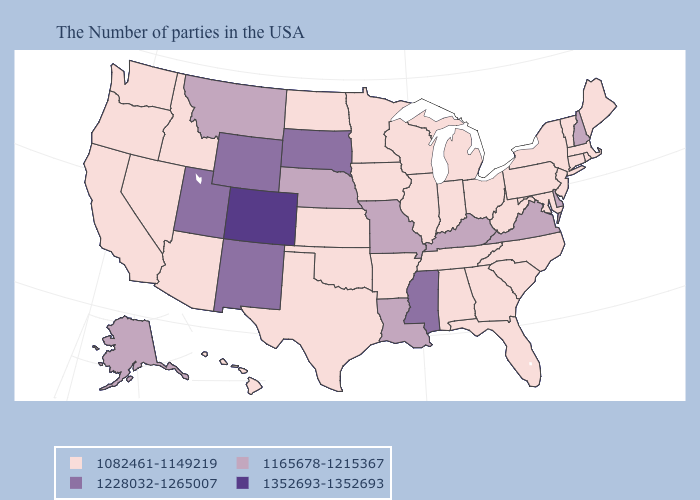Name the states that have a value in the range 1228032-1265007?
Be succinct. Mississippi, South Dakota, Wyoming, New Mexico, Utah. Name the states that have a value in the range 1165678-1215367?
Quick response, please. New Hampshire, Delaware, Virginia, Kentucky, Louisiana, Missouri, Nebraska, Montana, Alaska. Which states hav the highest value in the South?
Write a very short answer. Mississippi. Name the states that have a value in the range 1352693-1352693?
Be succinct. Colorado. Name the states that have a value in the range 1228032-1265007?
Quick response, please. Mississippi, South Dakota, Wyoming, New Mexico, Utah. Among the states that border North Dakota , which have the highest value?
Answer briefly. South Dakota. What is the highest value in states that border Massachusetts?
Short answer required. 1165678-1215367. Name the states that have a value in the range 1165678-1215367?
Short answer required. New Hampshire, Delaware, Virginia, Kentucky, Louisiana, Missouri, Nebraska, Montana, Alaska. What is the highest value in the USA?
Be succinct. 1352693-1352693. What is the value of Mississippi?
Keep it brief. 1228032-1265007. Is the legend a continuous bar?
Short answer required. No. What is the lowest value in the USA?
Short answer required. 1082461-1149219. What is the lowest value in the USA?
Write a very short answer. 1082461-1149219. Among the states that border Oregon , which have the lowest value?
Write a very short answer. Idaho, Nevada, California, Washington. What is the value of Nevada?
Concise answer only. 1082461-1149219. 